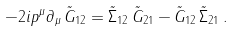<formula> <loc_0><loc_0><loc_500><loc_500>- 2 i p ^ { \mu } \partial _ { \mu } \, \tilde { G } _ { 1 2 } = \tilde { \Sigma } _ { 1 2 } \, \tilde { G } _ { 2 1 } - \tilde { G } _ { 1 2 } \, \tilde { \Sigma } _ { 2 1 } \, .</formula> 